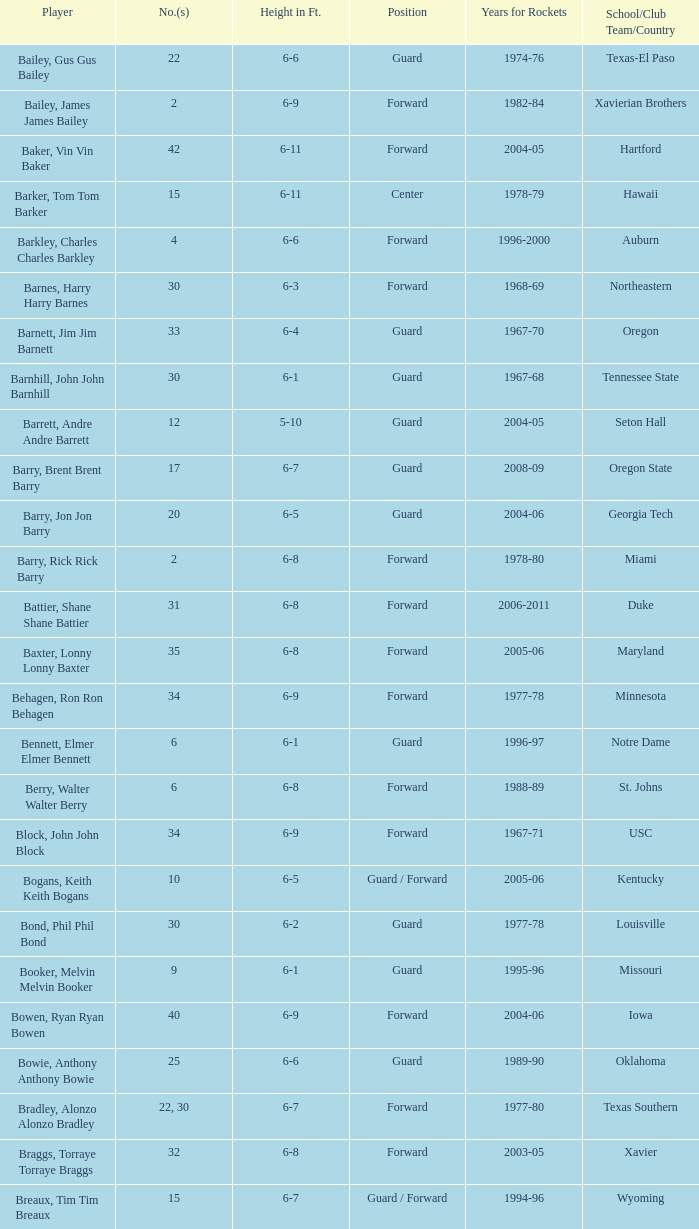What is the height of the player who attended Hartford? 6-11. 